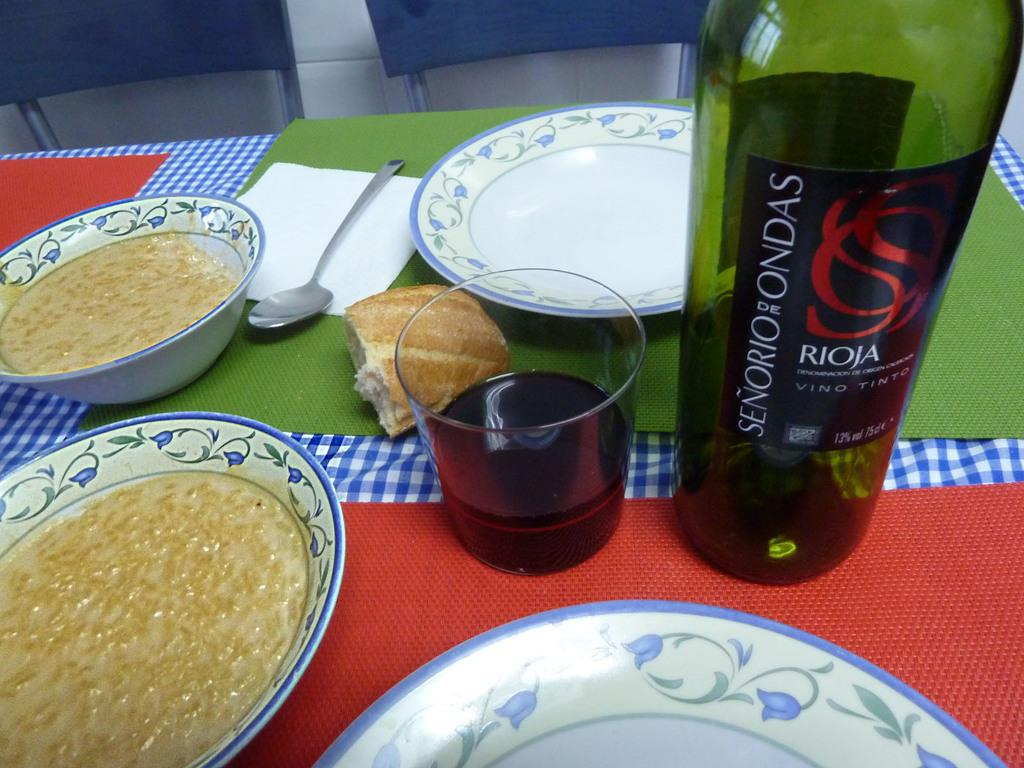Provide a one-sentence caption for the provided image. A colorful table with a bottle of red wine from Senerio de Ondas. 